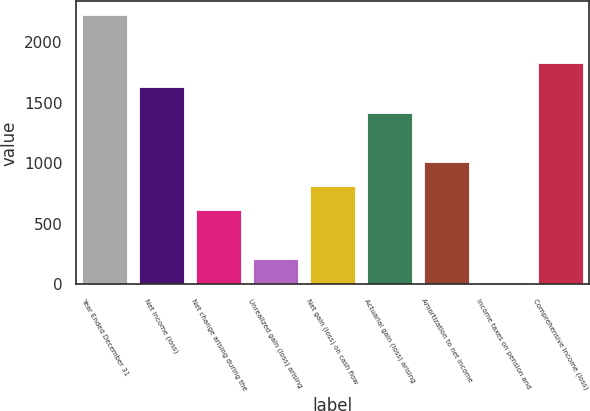<chart> <loc_0><loc_0><loc_500><loc_500><bar_chart><fcel>Year Ended December 31<fcel>Net income (loss)<fcel>Net change arising during the<fcel>Unrealized gain (loss) arising<fcel>Net gain (loss) on cash flow<fcel>Actuarial gain (loss) arising<fcel>Amortization to net income<fcel>Income taxes on pension and<fcel>Comprehensive income (loss)<nl><fcel>2227.9<fcel>1627<fcel>613.9<fcel>213.3<fcel>814.2<fcel>1415.1<fcel>1014.5<fcel>13<fcel>1827.3<nl></chart> 